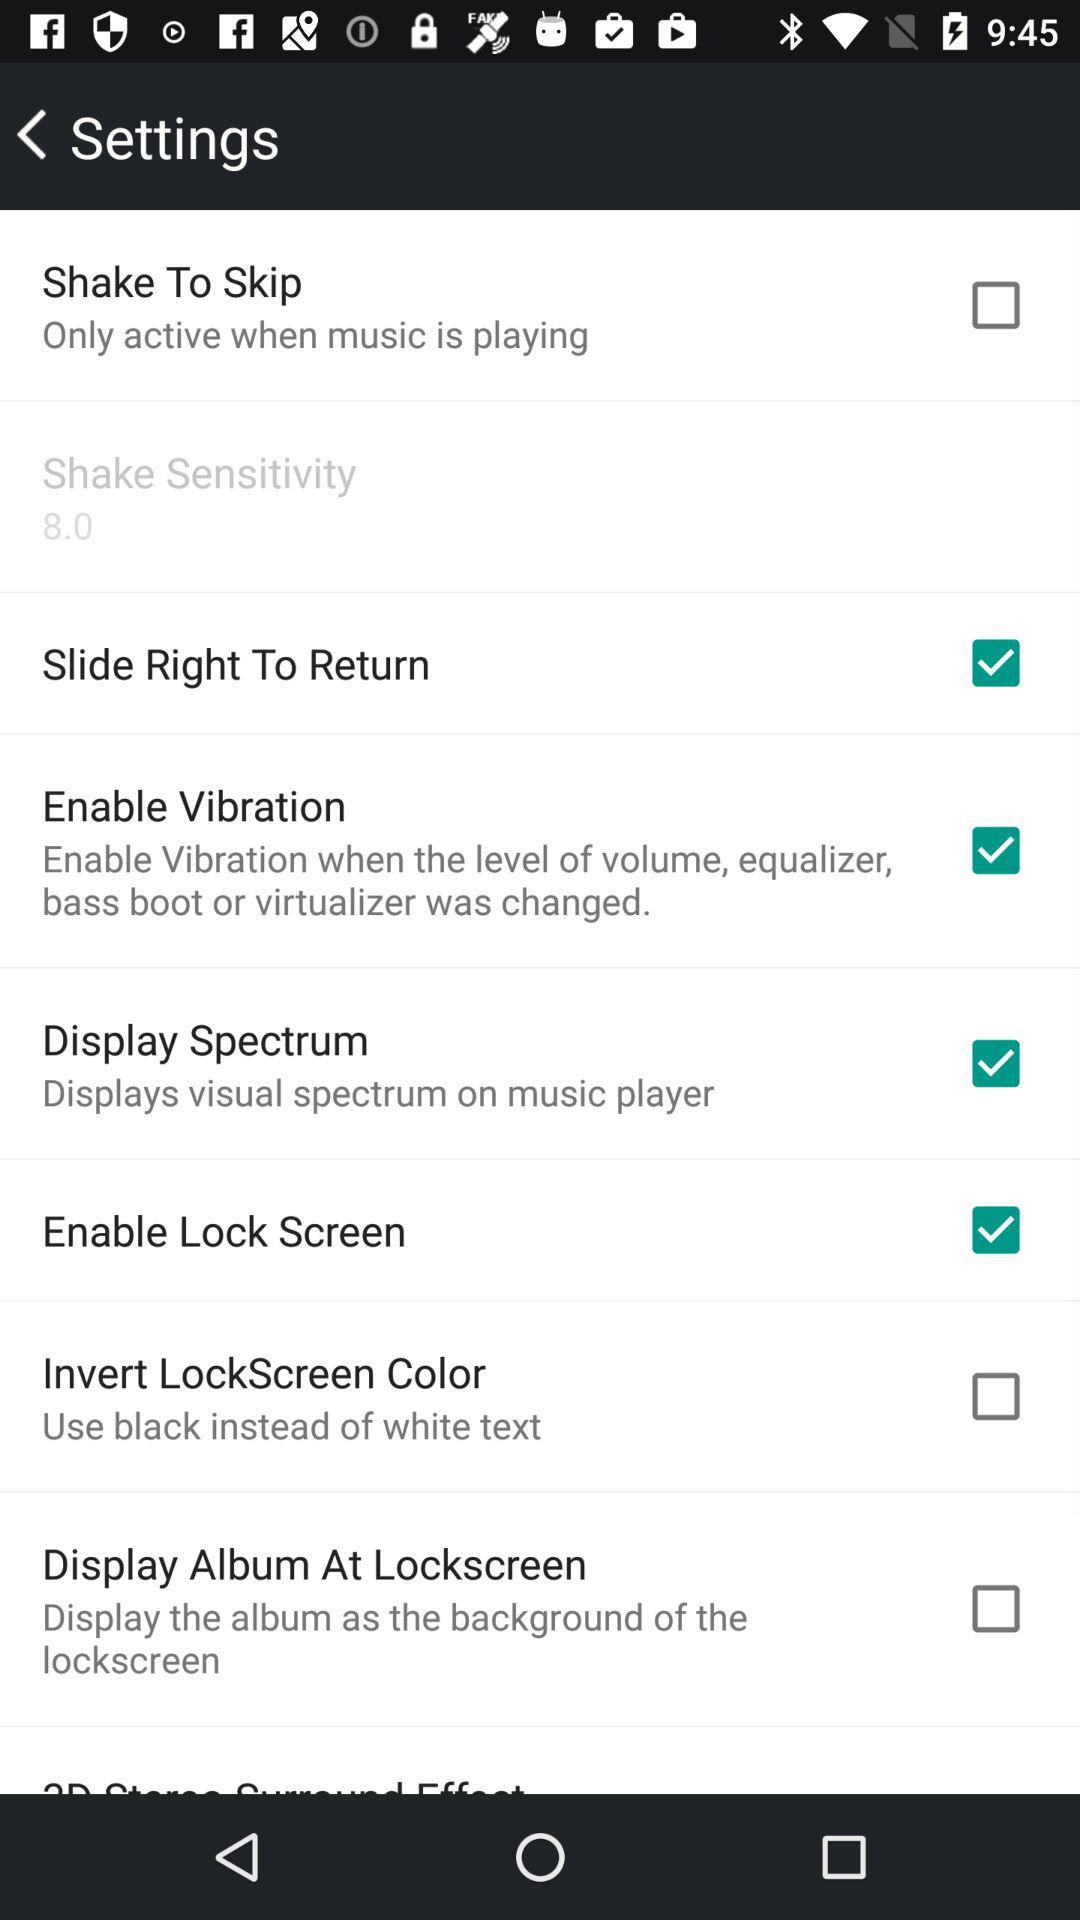What is the status of the "Enable Lock Screen"? The status is "on". 